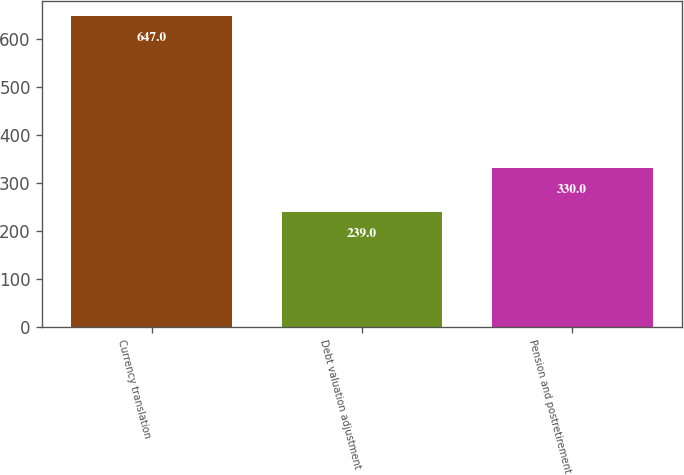Convert chart to OTSL. <chart><loc_0><loc_0><loc_500><loc_500><bar_chart><fcel>Currency translation<fcel>Debt valuation adjustment<fcel>Pension and postretirement<nl><fcel>647<fcel>239<fcel>330<nl></chart> 